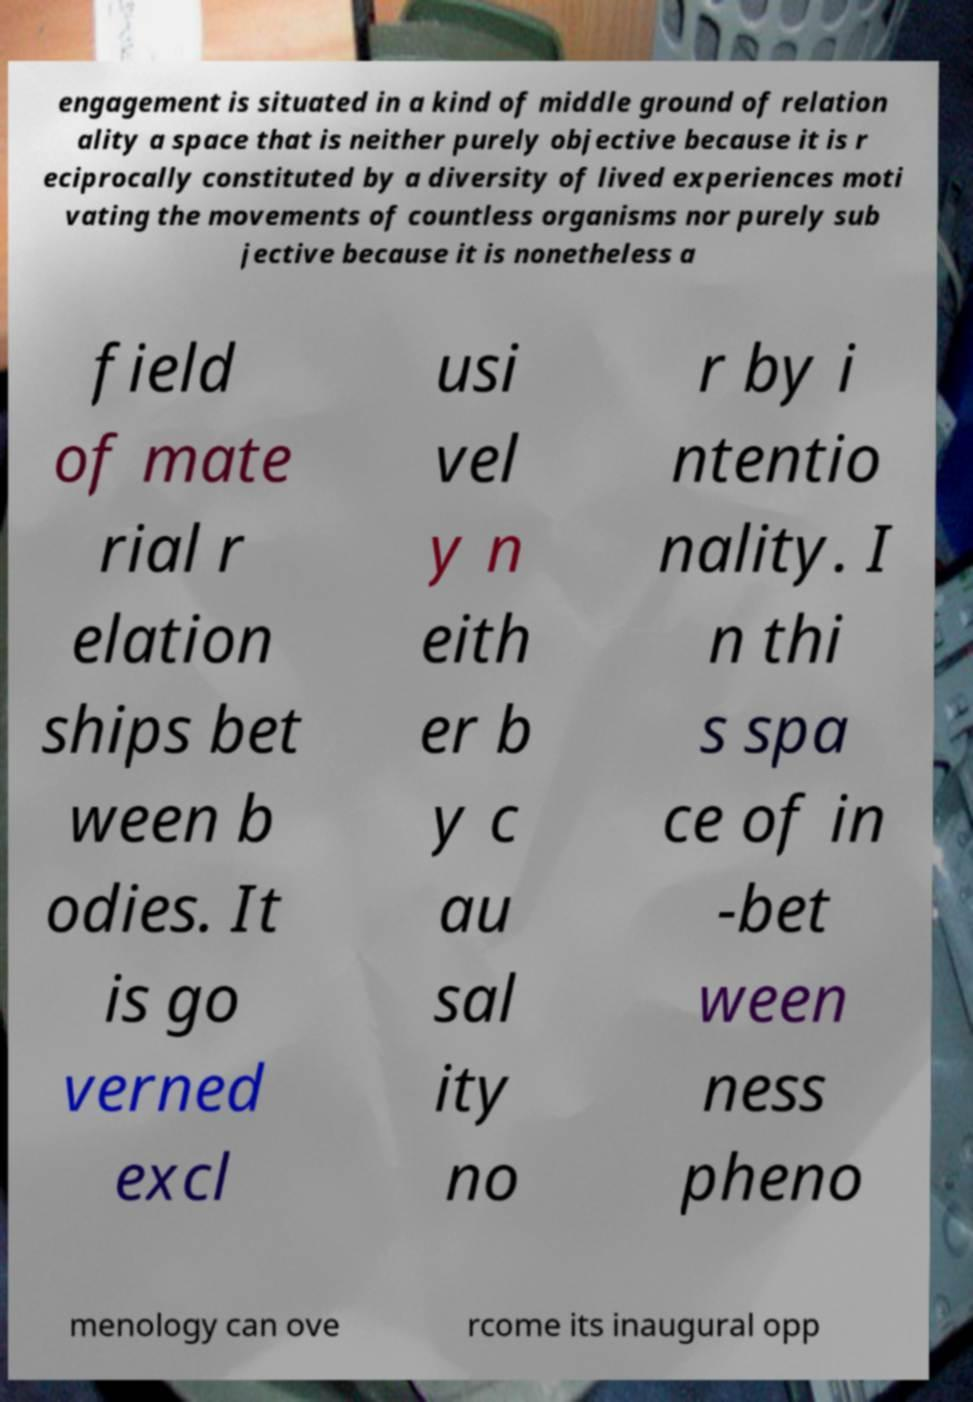I need the written content from this picture converted into text. Can you do that? engagement is situated in a kind of middle ground of relation ality a space that is neither purely objective because it is r eciprocally constituted by a diversity of lived experiences moti vating the movements of countless organisms nor purely sub jective because it is nonetheless a field of mate rial r elation ships bet ween b odies. It is go verned excl usi vel y n eith er b y c au sal ity no r by i ntentio nality. I n thi s spa ce of in -bet ween ness pheno menology can ove rcome its inaugural opp 